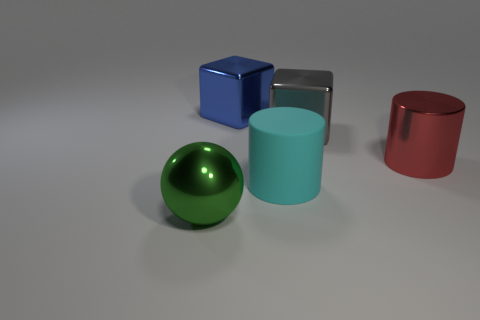Add 4 big red cylinders. How many objects exist? 9 Subtract all cubes. How many objects are left? 3 Subtract 0 yellow cylinders. How many objects are left? 5 Subtract all big gray shiny cubes. Subtract all green balls. How many objects are left? 3 Add 4 big green things. How many big green things are left? 5 Add 1 red shiny cylinders. How many red shiny cylinders exist? 2 